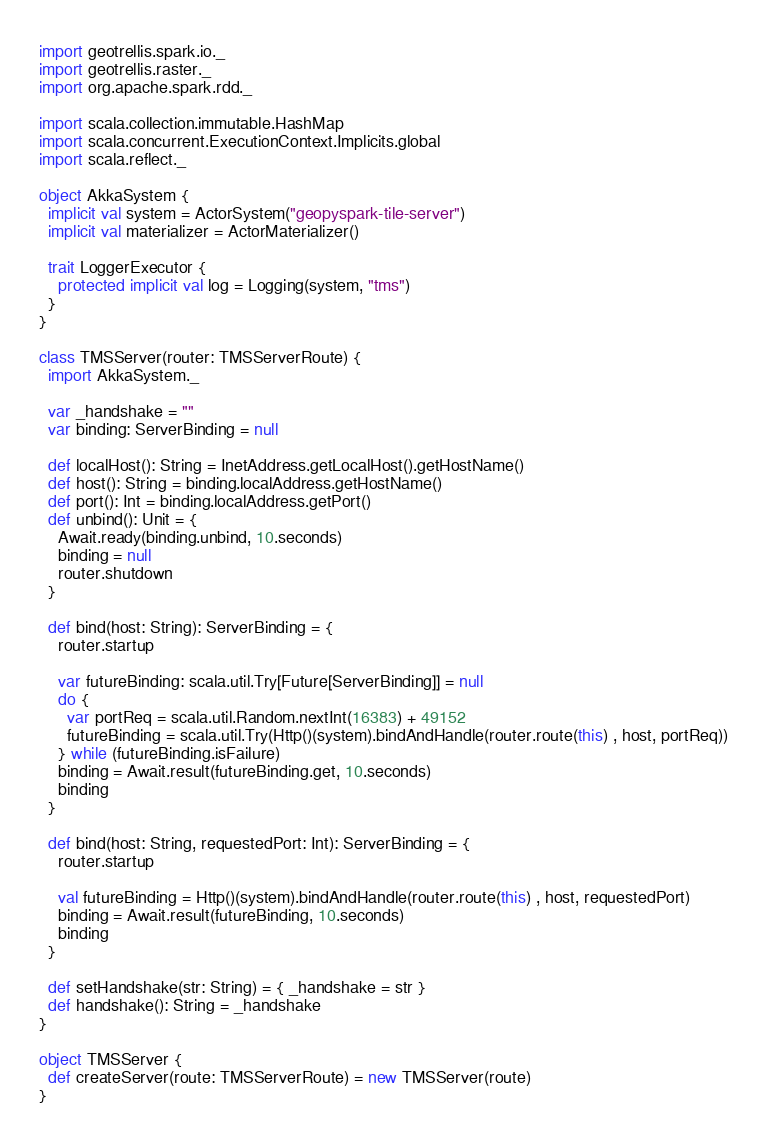Convert code to text. <code><loc_0><loc_0><loc_500><loc_500><_Scala_>import geotrellis.spark.io._
import geotrellis.raster._
import org.apache.spark.rdd._

import scala.collection.immutable.HashMap
import scala.concurrent.ExecutionContext.Implicits.global
import scala.reflect._

object AkkaSystem {
  implicit val system = ActorSystem("geopyspark-tile-server")
  implicit val materializer = ActorMaterializer()

  trait LoggerExecutor {
    protected implicit val log = Logging(system, "tms")
  }
}

class TMSServer(router: TMSServerRoute) {
  import AkkaSystem._

  var _handshake = ""
  var binding: ServerBinding = null

  def localHost(): String = InetAddress.getLocalHost().getHostName()
  def host(): String = binding.localAddress.getHostName()
  def port(): Int = binding.localAddress.getPort()
  def unbind(): Unit = {
    Await.ready(binding.unbind, 10.seconds)
    binding = null
    router.shutdown
  }

  def bind(host: String): ServerBinding = {
    router.startup

    var futureBinding: scala.util.Try[Future[ServerBinding]] = null
    do {
      var portReq = scala.util.Random.nextInt(16383) + 49152
      futureBinding = scala.util.Try(Http()(system).bindAndHandle(router.route(this) , host, portReq))
    } while (futureBinding.isFailure)
    binding = Await.result(futureBinding.get, 10.seconds)
    binding
  }

  def bind(host: String, requestedPort: Int): ServerBinding = {
    router.startup

    val futureBinding = Http()(system).bindAndHandle(router.route(this) , host, requestedPort)
    binding = Await.result(futureBinding, 10.seconds)
    binding
  }

  def setHandshake(str: String) = { _handshake = str }
  def handshake(): String = _handshake
}

object TMSServer {
  def createServer(route: TMSServerRoute) = new TMSServer(route)
}
</code> 